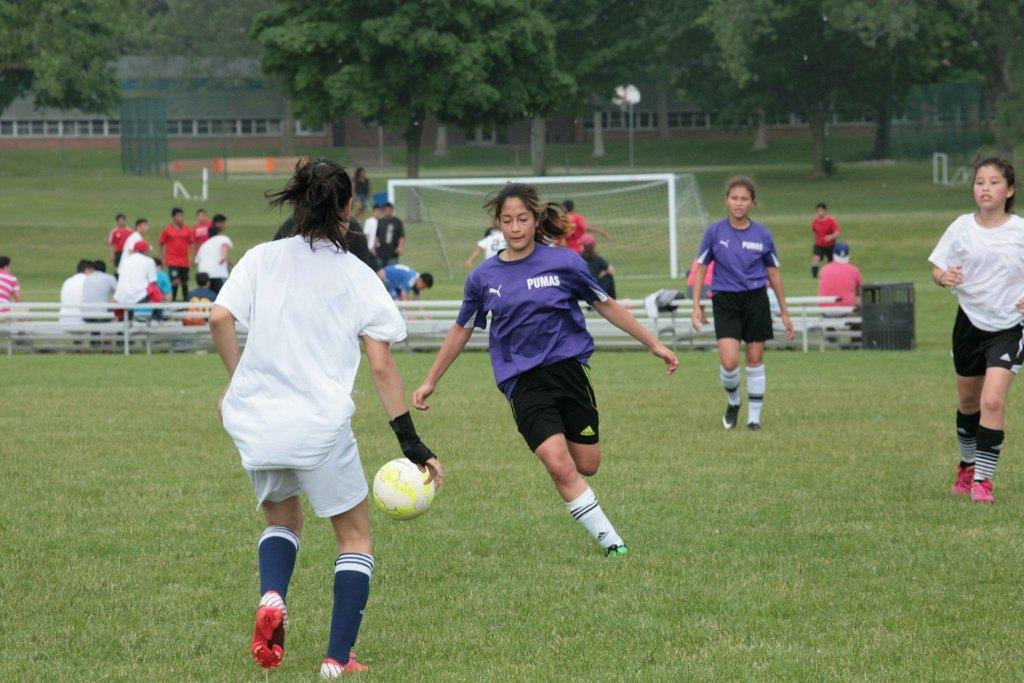<image>
Summarize the visual content of the image. a team called the Pumas playing soccer on a field 